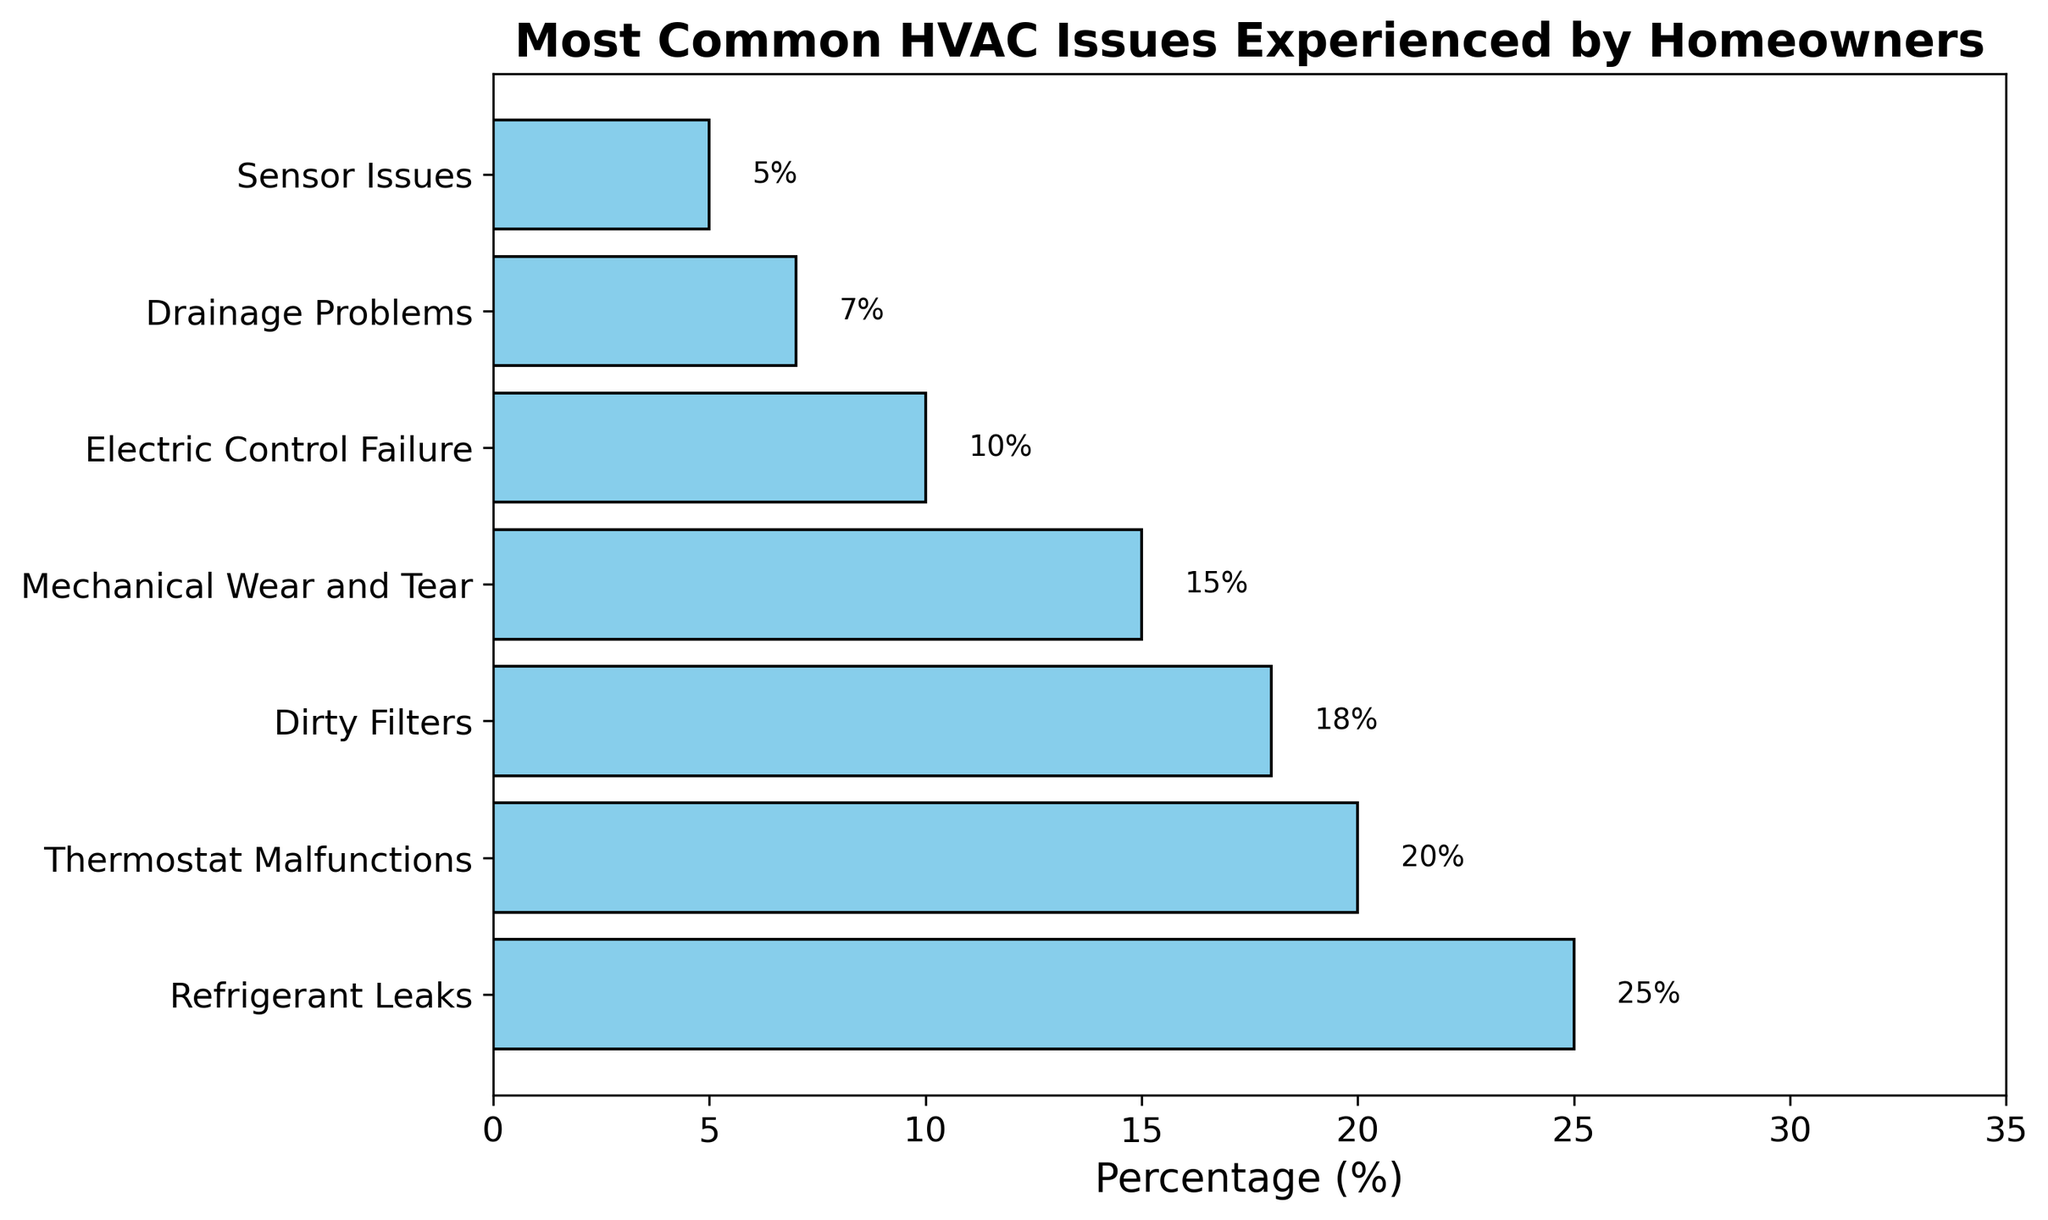What's the most common HVAC issue homeowners experience? Look at the bar with the highest percentage. The bar for "Refrigerant Leaks" is the longest and has a percentage of 25%.
Answer: Refrigerant Leaks Which HVAC issue is experienced by 20% of homeowners? Find the bar with a label that corresponds to 20%. The "Thermostat Malfunctions" bar matches this percentage.
Answer: Thermostat Malfunctions Which HVAC issues have a percentage less than 10%? Find bars that have a length corresponding to less than 10%. These issues are "Drainage Problems" at 7% and "Sensor Issues" at 5%.
Answer: Drainage Problems, Sensor Issues What's the combined percentage of homeowners experiencing Refrigerant Leaks and Dirty Filters? Add the percentages of Refrigerant Leaks and Dirty Filters: 25% + 18%.
Answer: 43% How much more common are Refrigerant Leaks compared to Electric Control Failure? Subtract the percentage of Electric Control Failure from Refrigerant Leaks: 25% - 10%.
Answer: 15% Among Mechanical Wear and Tear and Thermostat Malfunctions, which is more common? Compare the lengths of the bars for Mechanical Wear and Tear (15%) and Thermostat Malfunctions (20%). Thermostat Malfunctions is longer.
Answer: Thermostat Malfunctions What is the difference in percentage between the least common and most common HVAC issues? Subtract the percentage of the least common issue (Sensor Issues at 5%) from the most common issue (Refrigerant Leaks at 25%): 25% - 5%.
Answer: 20% What percentage of homeowners experience either Electric Control Failure or Sensor Issues? Add the percentages of Electric Control Failure and Sensor Issues: 10% + 5%.
Answer: 15% Which HVAC issues occur more frequently than 15%? Identify bars with lengths greater than 15%. These are Refrigerant Leaks (25%), Thermostat Malfunctions (20%), and Dirty Filters (18%).
Answer: Refrigerant Leaks, Thermostat Malfunctions, Dirty Filters If 10% of homeowners experience Mechanical Wear and Tear, how does this compare to the percentage experiencing Dirty Filters? Compare the percentage of Mechanical Wear and Tear (10%) with Dirty Filters (18%). Mechanical Wear and Tear is less common.
Answer: less common 